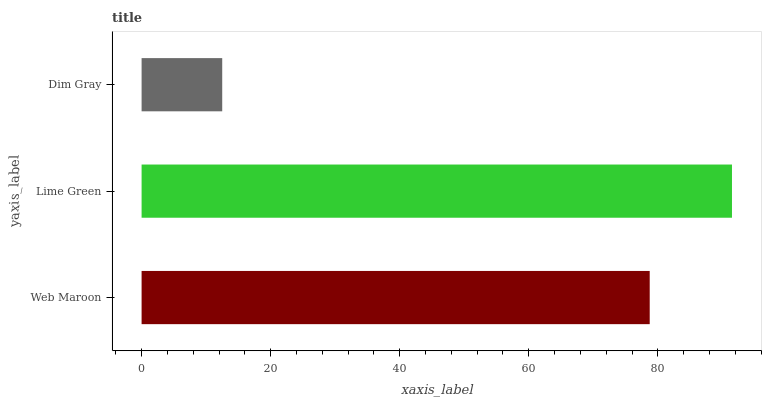Is Dim Gray the minimum?
Answer yes or no. Yes. Is Lime Green the maximum?
Answer yes or no. Yes. Is Lime Green the minimum?
Answer yes or no. No. Is Dim Gray the maximum?
Answer yes or no. No. Is Lime Green greater than Dim Gray?
Answer yes or no. Yes. Is Dim Gray less than Lime Green?
Answer yes or no. Yes. Is Dim Gray greater than Lime Green?
Answer yes or no. No. Is Lime Green less than Dim Gray?
Answer yes or no. No. Is Web Maroon the high median?
Answer yes or no. Yes. Is Web Maroon the low median?
Answer yes or no. Yes. Is Lime Green the high median?
Answer yes or no. No. Is Dim Gray the low median?
Answer yes or no. No. 